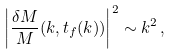Convert formula to latex. <formula><loc_0><loc_0><loc_500><loc_500>\left | { \frac { \delta M } { M } } ( k , t _ { f } ( k ) ) \right | ^ { 2 } \sim k ^ { 2 } \, ,</formula> 